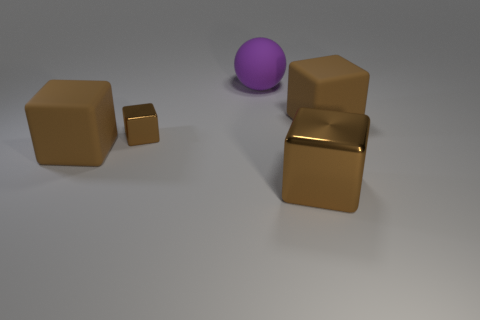How many brown cubes must be subtracted to get 1 brown cubes? 3 Subtract all purple cubes. Subtract all red cylinders. How many cubes are left? 4 Add 4 big objects. How many objects exist? 9 Subtract all balls. How many objects are left? 4 Add 1 big brown metal objects. How many big brown metal objects are left? 2 Add 2 tiny purple matte objects. How many tiny purple matte objects exist? 2 Subtract 0 red cylinders. How many objects are left? 5 Subtract all large blue matte cylinders. Subtract all small blocks. How many objects are left? 4 